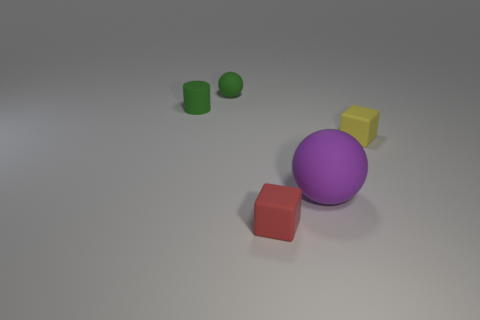Add 1 large purple matte blocks. How many objects exist? 6 Subtract all purple spheres. How many spheres are left? 1 Subtract all cylinders. How many objects are left? 4 Add 1 small green rubber spheres. How many small green rubber spheres are left? 2 Add 2 rubber things. How many rubber things exist? 7 Subtract 0 cyan cubes. How many objects are left? 5 Subtract all blue cylinders. Subtract all red cubes. How many cylinders are left? 1 Subtract all small gray metallic spheres. Subtract all tiny yellow objects. How many objects are left? 4 